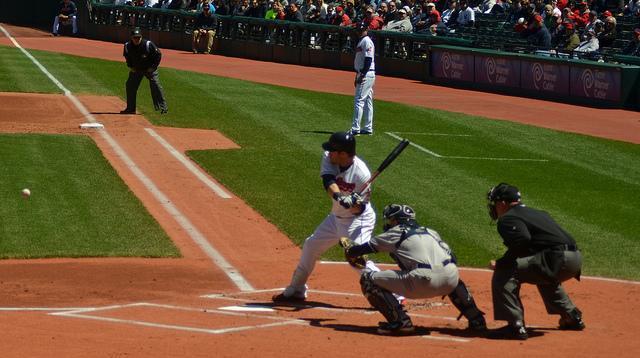How many people can you see?
Give a very brief answer. 5. How many candles on the cake are not lit?
Give a very brief answer. 0. 